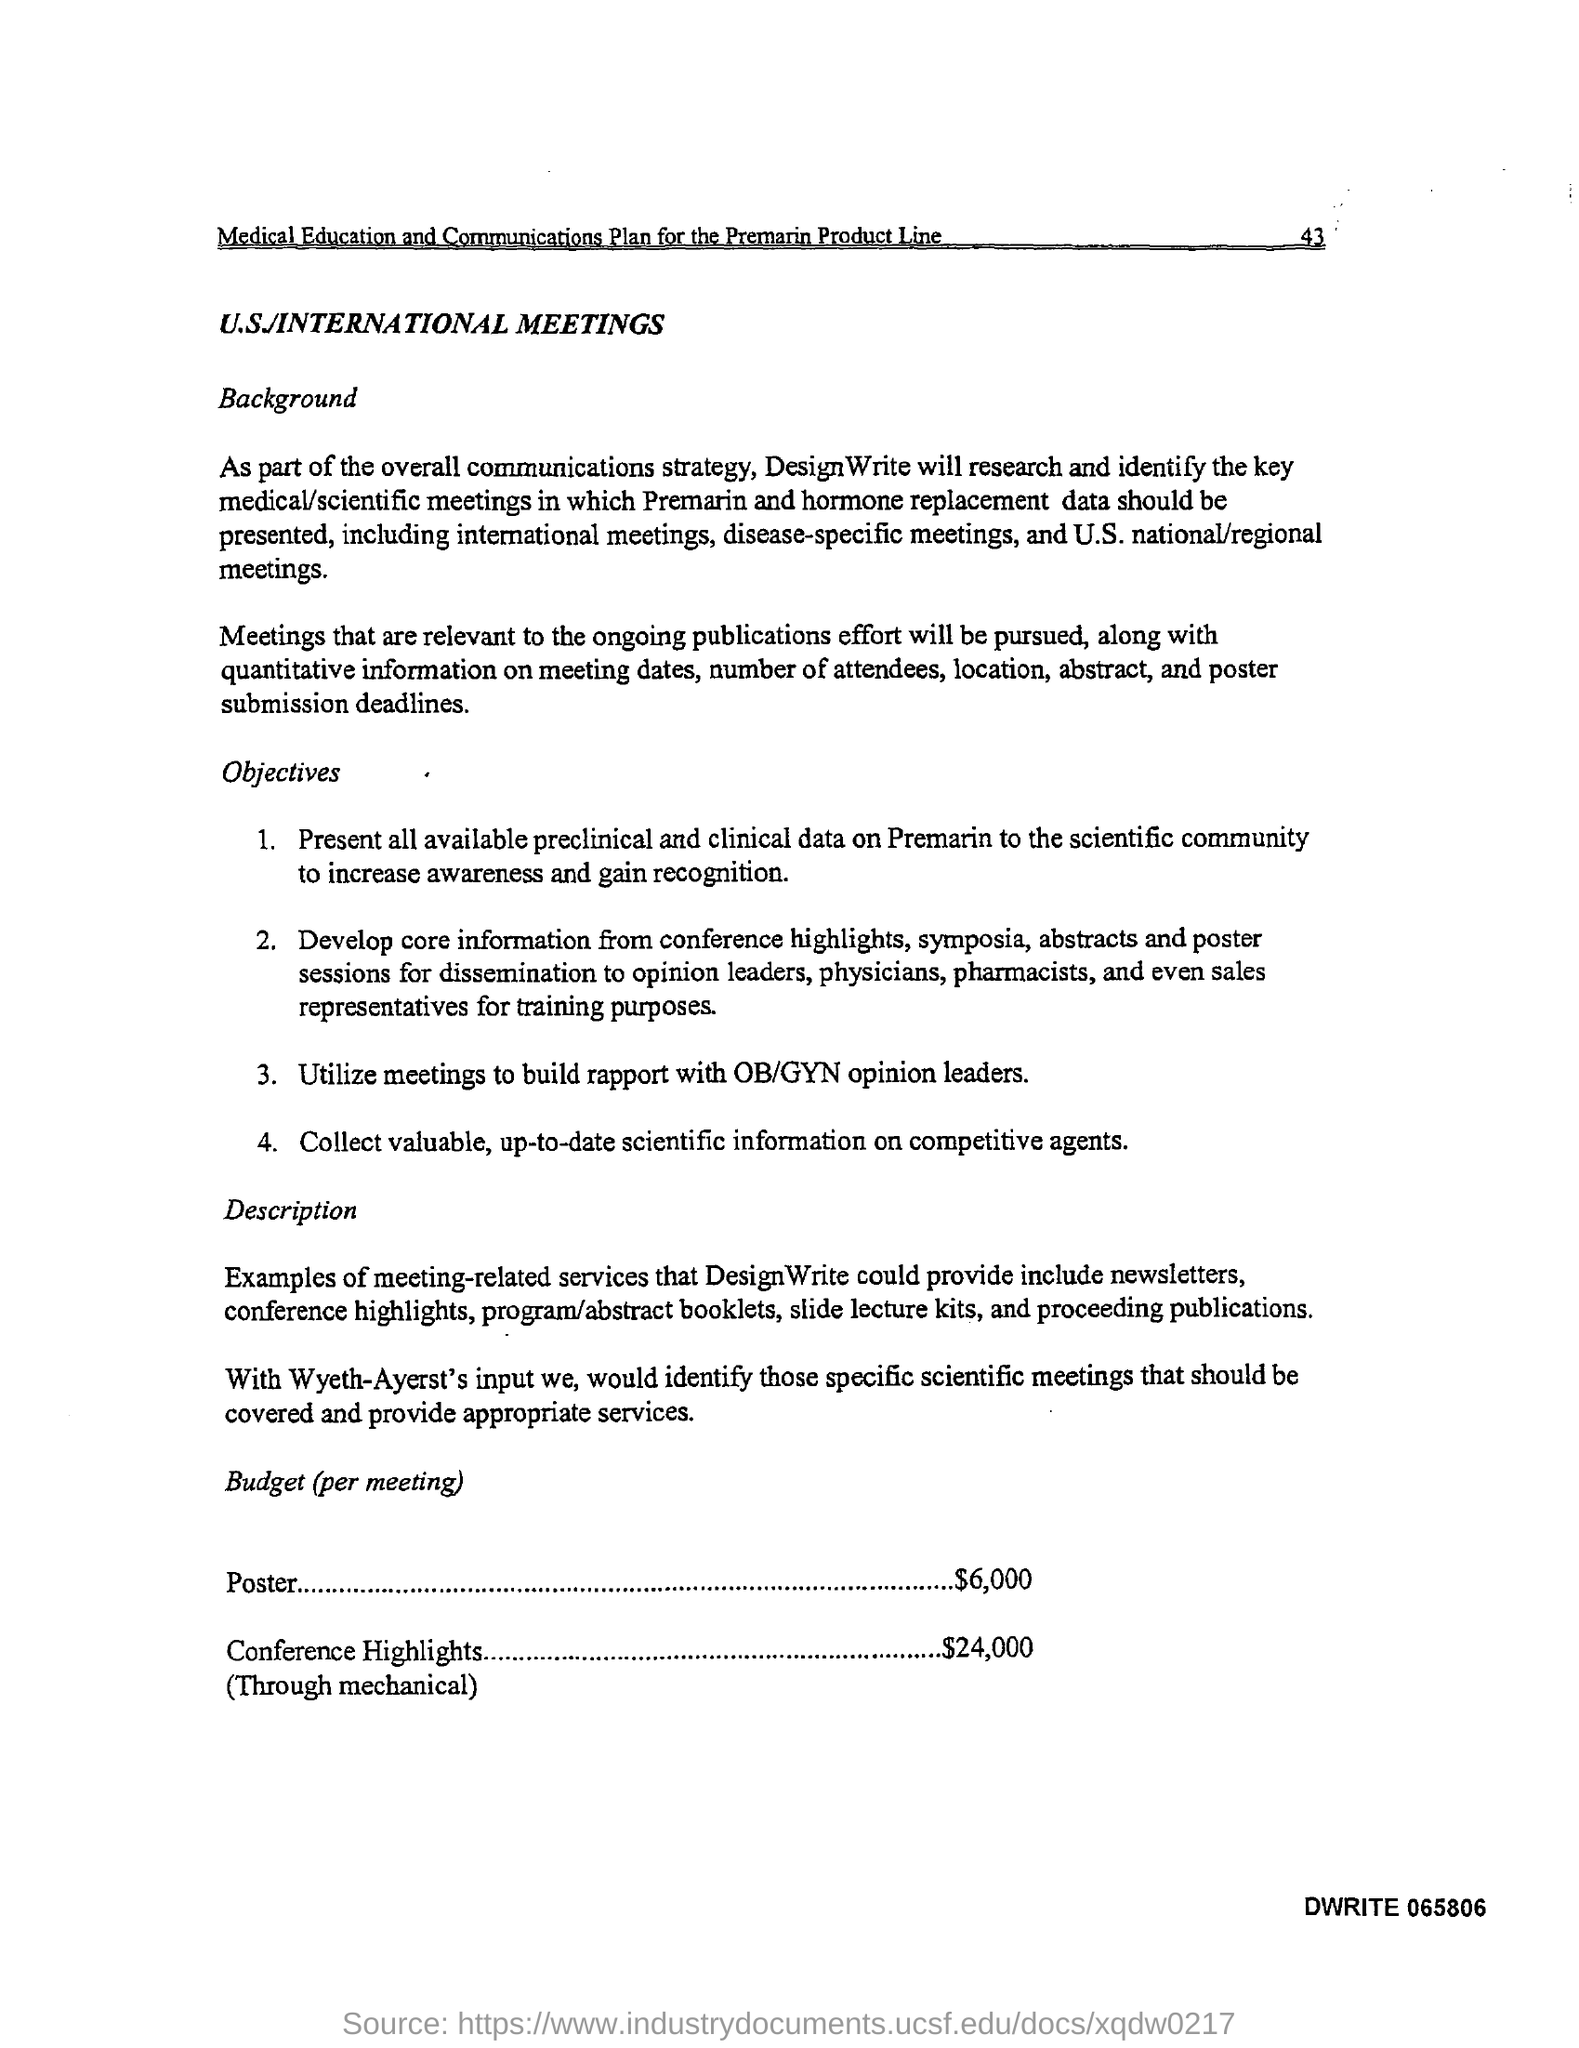What is the amount of budget given for poster (per meeting)?
Provide a short and direct response. $6,000. What is the budget given for conference highlights ?
Your answer should be compact. $24,000. 